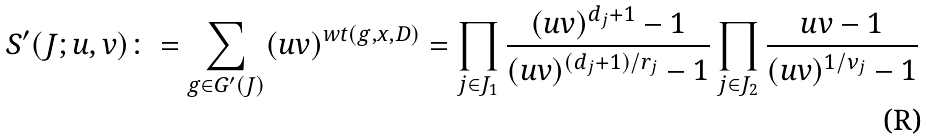<formula> <loc_0><loc_0><loc_500><loc_500>S ^ { \prime } ( J ; u , v ) \colon = \sum _ { g \in G ^ { \prime } ( J ) } ( u v ) ^ { w t ( g , x , D ) } = \prod _ { j \in J _ { 1 } } \frac { ( u v ) ^ { d _ { j } + 1 } - 1 } { ( u v ) ^ { ( d _ { j } + 1 ) / r _ { j } } - 1 } \prod _ { j \in J _ { 2 } } \frac { u v - 1 } { ( u v ) ^ { 1 / \nu _ { j } } - 1 }</formula> 